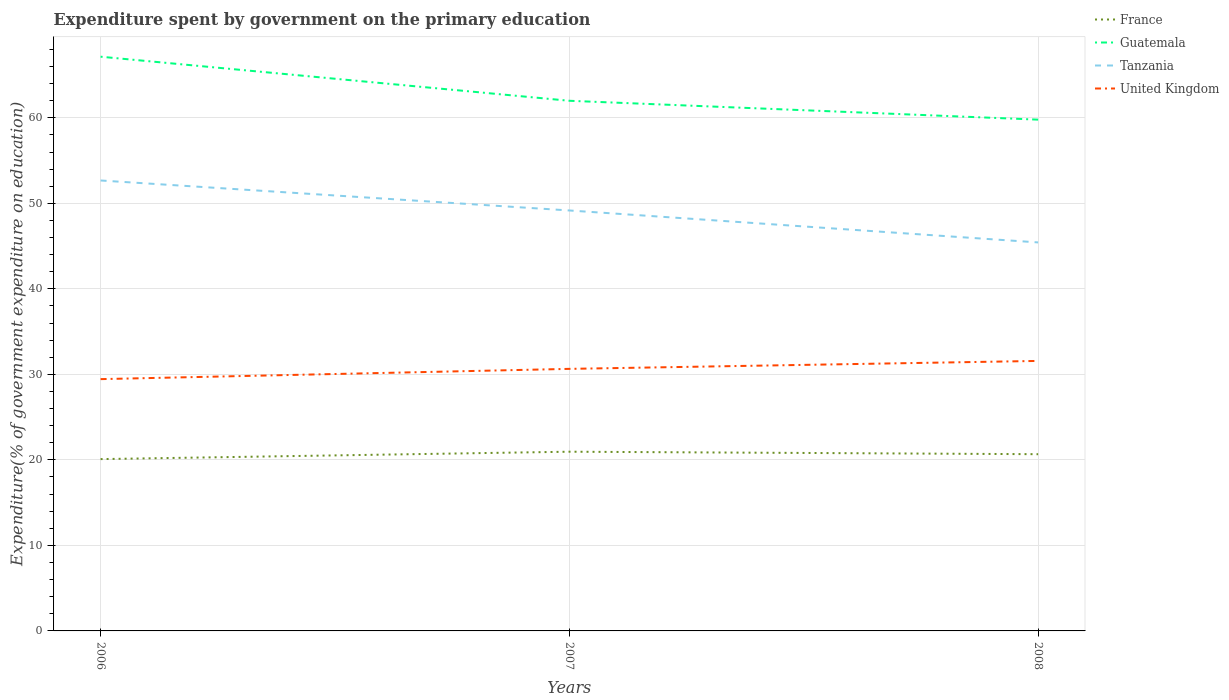How many different coloured lines are there?
Give a very brief answer. 4. Is the number of lines equal to the number of legend labels?
Ensure brevity in your answer.  Yes. Across all years, what is the maximum expenditure spent by government on the primary education in Tanzania?
Offer a very short reply. 45.43. What is the total expenditure spent by government on the primary education in Guatemala in the graph?
Offer a very short reply. 2.21. What is the difference between the highest and the second highest expenditure spent by government on the primary education in France?
Keep it short and to the point. 0.86. Is the expenditure spent by government on the primary education in Guatemala strictly greater than the expenditure spent by government on the primary education in United Kingdom over the years?
Make the answer very short. No. What is the difference between two consecutive major ticks on the Y-axis?
Your response must be concise. 10. Does the graph contain any zero values?
Make the answer very short. No. Where does the legend appear in the graph?
Make the answer very short. Top right. How are the legend labels stacked?
Your response must be concise. Vertical. What is the title of the graph?
Your answer should be compact. Expenditure spent by government on the primary education. What is the label or title of the X-axis?
Your answer should be very brief. Years. What is the label or title of the Y-axis?
Offer a terse response. Expenditure(% of government expenditure on education). What is the Expenditure(% of government expenditure on education) in France in 2006?
Give a very brief answer. 20.09. What is the Expenditure(% of government expenditure on education) of Guatemala in 2006?
Ensure brevity in your answer.  67.15. What is the Expenditure(% of government expenditure on education) of Tanzania in 2006?
Give a very brief answer. 52.68. What is the Expenditure(% of government expenditure on education) of United Kingdom in 2006?
Your response must be concise. 29.45. What is the Expenditure(% of government expenditure on education) in France in 2007?
Your answer should be very brief. 20.96. What is the Expenditure(% of government expenditure on education) of Guatemala in 2007?
Ensure brevity in your answer.  62. What is the Expenditure(% of government expenditure on education) in Tanzania in 2007?
Make the answer very short. 49.17. What is the Expenditure(% of government expenditure on education) in United Kingdom in 2007?
Provide a short and direct response. 30.65. What is the Expenditure(% of government expenditure on education) of France in 2008?
Give a very brief answer. 20.67. What is the Expenditure(% of government expenditure on education) of Guatemala in 2008?
Make the answer very short. 59.79. What is the Expenditure(% of government expenditure on education) in Tanzania in 2008?
Keep it short and to the point. 45.43. What is the Expenditure(% of government expenditure on education) of United Kingdom in 2008?
Make the answer very short. 31.58. Across all years, what is the maximum Expenditure(% of government expenditure on education) in France?
Ensure brevity in your answer.  20.96. Across all years, what is the maximum Expenditure(% of government expenditure on education) in Guatemala?
Your answer should be very brief. 67.15. Across all years, what is the maximum Expenditure(% of government expenditure on education) of Tanzania?
Your answer should be compact. 52.68. Across all years, what is the maximum Expenditure(% of government expenditure on education) in United Kingdom?
Provide a short and direct response. 31.58. Across all years, what is the minimum Expenditure(% of government expenditure on education) in France?
Provide a short and direct response. 20.09. Across all years, what is the minimum Expenditure(% of government expenditure on education) of Guatemala?
Ensure brevity in your answer.  59.79. Across all years, what is the minimum Expenditure(% of government expenditure on education) of Tanzania?
Ensure brevity in your answer.  45.43. Across all years, what is the minimum Expenditure(% of government expenditure on education) in United Kingdom?
Your answer should be very brief. 29.45. What is the total Expenditure(% of government expenditure on education) in France in the graph?
Give a very brief answer. 61.72. What is the total Expenditure(% of government expenditure on education) in Guatemala in the graph?
Make the answer very short. 188.94. What is the total Expenditure(% of government expenditure on education) of Tanzania in the graph?
Offer a terse response. 147.28. What is the total Expenditure(% of government expenditure on education) of United Kingdom in the graph?
Give a very brief answer. 91.67. What is the difference between the Expenditure(% of government expenditure on education) in France in 2006 and that in 2007?
Make the answer very short. -0.86. What is the difference between the Expenditure(% of government expenditure on education) in Guatemala in 2006 and that in 2007?
Make the answer very short. 5.16. What is the difference between the Expenditure(% of government expenditure on education) in Tanzania in 2006 and that in 2007?
Give a very brief answer. 3.51. What is the difference between the Expenditure(% of government expenditure on education) of United Kingdom in 2006 and that in 2007?
Provide a short and direct response. -1.2. What is the difference between the Expenditure(% of government expenditure on education) in France in 2006 and that in 2008?
Offer a terse response. -0.57. What is the difference between the Expenditure(% of government expenditure on education) in Guatemala in 2006 and that in 2008?
Ensure brevity in your answer.  7.36. What is the difference between the Expenditure(% of government expenditure on education) of Tanzania in 2006 and that in 2008?
Keep it short and to the point. 7.24. What is the difference between the Expenditure(% of government expenditure on education) in United Kingdom in 2006 and that in 2008?
Your answer should be very brief. -2.13. What is the difference between the Expenditure(% of government expenditure on education) in France in 2007 and that in 2008?
Offer a very short reply. 0.29. What is the difference between the Expenditure(% of government expenditure on education) of Guatemala in 2007 and that in 2008?
Offer a very short reply. 2.21. What is the difference between the Expenditure(% of government expenditure on education) in Tanzania in 2007 and that in 2008?
Your answer should be very brief. 3.74. What is the difference between the Expenditure(% of government expenditure on education) in United Kingdom in 2007 and that in 2008?
Ensure brevity in your answer.  -0.93. What is the difference between the Expenditure(% of government expenditure on education) of France in 2006 and the Expenditure(% of government expenditure on education) of Guatemala in 2007?
Your answer should be compact. -41.9. What is the difference between the Expenditure(% of government expenditure on education) of France in 2006 and the Expenditure(% of government expenditure on education) of Tanzania in 2007?
Your answer should be compact. -29.07. What is the difference between the Expenditure(% of government expenditure on education) of France in 2006 and the Expenditure(% of government expenditure on education) of United Kingdom in 2007?
Ensure brevity in your answer.  -10.55. What is the difference between the Expenditure(% of government expenditure on education) in Guatemala in 2006 and the Expenditure(% of government expenditure on education) in Tanzania in 2007?
Offer a very short reply. 17.98. What is the difference between the Expenditure(% of government expenditure on education) of Guatemala in 2006 and the Expenditure(% of government expenditure on education) of United Kingdom in 2007?
Your answer should be very brief. 36.51. What is the difference between the Expenditure(% of government expenditure on education) of Tanzania in 2006 and the Expenditure(% of government expenditure on education) of United Kingdom in 2007?
Offer a terse response. 22.03. What is the difference between the Expenditure(% of government expenditure on education) of France in 2006 and the Expenditure(% of government expenditure on education) of Guatemala in 2008?
Make the answer very short. -39.7. What is the difference between the Expenditure(% of government expenditure on education) in France in 2006 and the Expenditure(% of government expenditure on education) in Tanzania in 2008?
Offer a very short reply. -25.34. What is the difference between the Expenditure(% of government expenditure on education) of France in 2006 and the Expenditure(% of government expenditure on education) of United Kingdom in 2008?
Offer a terse response. -11.48. What is the difference between the Expenditure(% of government expenditure on education) in Guatemala in 2006 and the Expenditure(% of government expenditure on education) in Tanzania in 2008?
Keep it short and to the point. 21.72. What is the difference between the Expenditure(% of government expenditure on education) of Guatemala in 2006 and the Expenditure(% of government expenditure on education) of United Kingdom in 2008?
Keep it short and to the point. 35.58. What is the difference between the Expenditure(% of government expenditure on education) in Tanzania in 2006 and the Expenditure(% of government expenditure on education) in United Kingdom in 2008?
Your response must be concise. 21.1. What is the difference between the Expenditure(% of government expenditure on education) of France in 2007 and the Expenditure(% of government expenditure on education) of Guatemala in 2008?
Offer a very short reply. -38.83. What is the difference between the Expenditure(% of government expenditure on education) in France in 2007 and the Expenditure(% of government expenditure on education) in Tanzania in 2008?
Your answer should be very brief. -24.47. What is the difference between the Expenditure(% of government expenditure on education) of France in 2007 and the Expenditure(% of government expenditure on education) of United Kingdom in 2008?
Make the answer very short. -10.62. What is the difference between the Expenditure(% of government expenditure on education) of Guatemala in 2007 and the Expenditure(% of government expenditure on education) of Tanzania in 2008?
Keep it short and to the point. 16.56. What is the difference between the Expenditure(% of government expenditure on education) in Guatemala in 2007 and the Expenditure(% of government expenditure on education) in United Kingdom in 2008?
Offer a very short reply. 30.42. What is the difference between the Expenditure(% of government expenditure on education) in Tanzania in 2007 and the Expenditure(% of government expenditure on education) in United Kingdom in 2008?
Give a very brief answer. 17.59. What is the average Expenditure(% of government expenditure on education) of France per year?
Your answer should be compact. 20.57. What is the average Expenditure(% of government expenditure on education) of Guatemala per year?
Offer a terse response. 62.98. What is the average Expenditure(% of government expenditure on education) in Tanzania per year?
Give a very brief answer. 49.09. What is the average Expenditure(% of government expenditure on education) in United Kingdom per year?
Make the answer very short. 30.56. In the year 2006, what is the difference between the Expenditure(% of government expenditure on education) of France and Expenditure(% of government expenditure on education) of Guatemala?
Your answer should be compact. -47.06. In the year 2006, what is the difference between the Expenditure(% of government expenditure on education) of France and Expenditure(% of government expenditure on education) of Tanzania?
Your answer should be very brief. -32.58. In the year 2006, what is the difference between the Expenditure(% of government expenditure on education) of France and Expenditure(% of government expenditure on education) of United Kingdom?
Ensure brevity in your answer.  -9.35. In the year 2006, what is the difference between the Expenditure(% of government expenditure on education) in Guatemala and Expenditure(% of government expenditure on education) in Tanzania?
Give a very brief answer. 14.48. In the year 2006, what is the difference between the Expenditure(% of government expenditure on education) in Guatemala and Expenditure(% of government expenditure on education) in United Kingdom?
Make the answer very short. 37.71. In the year 2006, what is the difference between the Expenditure(% of government expenditure on education) in Tanzania and Expenditure(% of government expenditure on education) in United Kingdom?
Provide a succinct answer. 23.23. In the year 2007, what is the difference between the Expenditure(% of government expenditure on education) of France and Expenditure(% of government expenditure on education) of Guatemala?
Your response must be concise. -41.04. In the year 2007, what is the difference between the Expenditure(% of government expenditure on education) in France and Expenditure(% of government expenditure on education) in Tanzania?
Offer a terse response. -28.21. In the year 2007, what is the difference between the Expenditure(% of government expenditure on education) of France and Expenditure(% of government expenditure on education) of United Kingdom?
Keep it short and to the point. -9.69. In the year 2007, what is the difference between the Expenditure(% of government expenditure on education) of Guatemala and Expenditure(% of government expenditure on education) of Tanzania?
Offer a very short reply. 12.83. In the year 2007, what is the difference between the Expenditure(% of government expenditure on education) in Guatemala and Expenditure(% of government expenditure on education) in United Kingdom?
Ensure brevity in your answer.  31.35. In the year 2007, what is the difference between the Expenditure(% of government expenditure on education) in Tanzania and Expenditure(% of government expenditure on education) in United Kingdom?
Your answer should be compact. 18.52. In the year 2008, what is the difference between the Expenditure(% of government expenditure on education) of France and Expenditure(% of government expenditure on education) of Guatemala?
Your response must be concise. -39.12. In the year 2008, what is the difference between the Expenditure(% of government expenditure on education) in France and Expenditure(% of government expenditure on education) in Tanzania?
Offer a terse response. -24.77. In the year 2008, what is the difference between the Expenditure(% of government expenditure on education) of France and Expenditure(% of government expenditure on education) of United Kingdom?
Your answer should be compact. -10.91. In the year 2008, what is the difference between the Expenditure(% of government expenditure on education) in Guatemala and Expenditure(% of government expenditure on education) in Tanzania?
Offer a terse response. 14.36. In the year 2008, what is the difference between the Expenditure(% of government expenditure on education) in Guatemala and Expenditure(% of government expenditure on education) in United Kingdom?
Your answer should be compact. 28.21. In the year 2008, what is the difference between the Expenditure(% of government expenditure on education) in Tanzania and Expenditure(% of government expenditure on education) in United Kingdom?
Give a very brief answer. 13.86. What is the ratio of the Expenditure(% of government expenditure on education) of France in 2006 to that in 2007?
Your answer should be very brief. 0.96. What is the ratio of the Expenditure(% of government expenditure on education) of Guatemala in 2006 to that in 2007?
Your answer should be very brief. 1.08. What is the ratio of the Expenditure(% of government expenditure on education) of Tanzania in 2006 to that in 2007?
Your answer should be very brief. 1.07. What is the ratio of the Expenditure(% of government expenditure on education) in United Kingdom in 2006 to that in 2007?
Provide a succinct answer. 0.96. What is the ratio of the Expenditure(% of government expenditure on education) in France in 2006 to that in 2008?
Offer a very short reply. 0.97. What is the ratio of the Expenditure(% of government expenditure on education) in Guatemala in 2006 to that in 2008?
Offer a terse response. 1.12. What is the ratio of the Expenditure(% of government expenditure on education) in Tanzania in 2006 to that in 2008?
Your answer should be very brief. 1.16. What is the ratio of the Expenditure(% of government expenditure on education) of United Kingdom in 2006 to that in 2008?
Offer a very short reply. 0.93. What is the ratio of the Expenditure(% of government expenditure on education) in France in 2007 to that in 2008?
Keep it short and to the point. 1.01. What is the ratio of the Expenditure(% of government expenditure on education) in Guatemala in 2007 to that in 2008?
Provide a short and direct response. 1.04. What is the ratio of the Expenditure(% of government expenditure on education) in Tanzania in 2007 to that in 2008?
Give a very brief answer. 1.08. What is the ratio of the Expenditure(% of government expenditure on education) in United Kingdom in 2007 to that in 2008?
Give a very brief answer. 0.97. What is the difference between the highest and the second highest Expenditure(% of government expenditure on education) of France?
Keep it short and to the point. 0.29. What is the difference between the highest and the second highest Expenditure(% of government expenditure on education) of Guatemala?
Your answer should be very brief. 5.16. What is the difference between the highest and the second highest Expenditure(% of government expenditure on education) of Tanzania?
Provide a short and direct response. 3.51. What is the difference between the highest and the second highest Expenditure(% of government expenditure on education) in United Kingdom?
Your response must be concise. 0.93. What is the difference between the highest and the lowest Expenditure(% of government expenditure on education) of France?
Make the answer very short. 0.86. What is the difference between the highest and the lowest Expenditure(% of government expenditure on education) of Guatemala?
Make the answer very short. 7.36. What is the difference between the highest and the lowest Expenditure(% of government expenditure on education) in Tanzania?
Give a very brief answer. 7.24. What is the difference between the highest and the lowest Expenditure(% of government expenditure on education) of United Kingdom?
Keep it short and to the point. 2.13. 